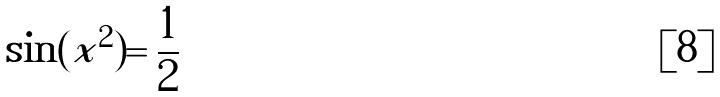<formula> <loc_0><loc_0><loc_500><loc_500>\sin ( x ^ { 2 } ) = \frac { 1 } { 2 }</formula> 